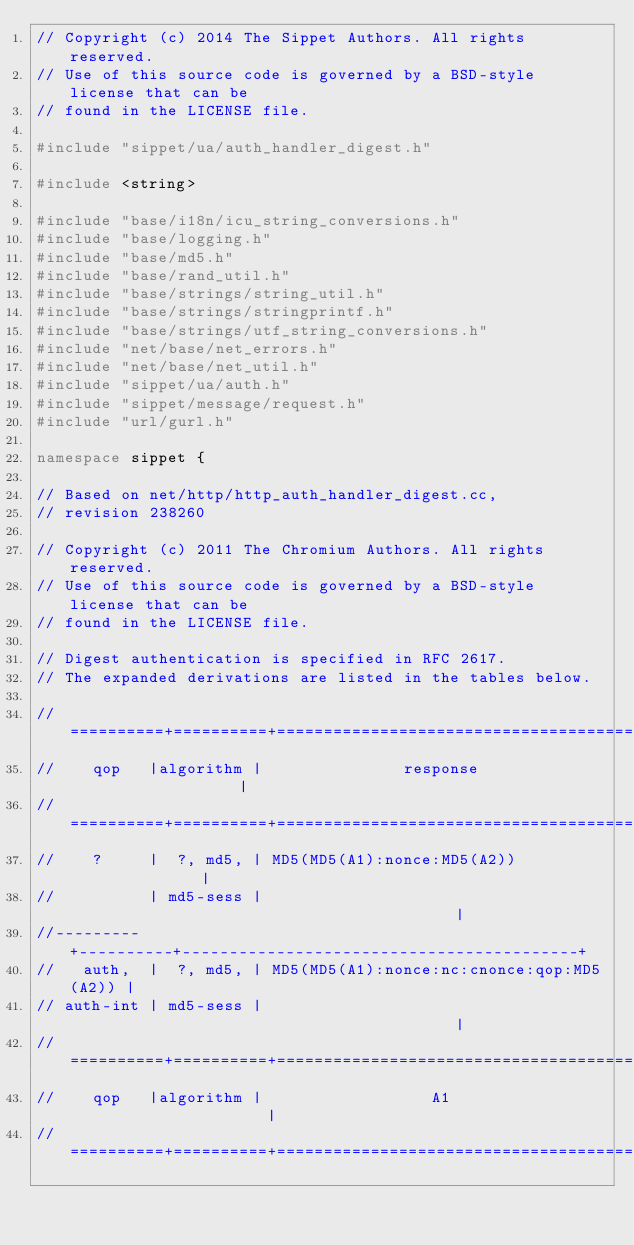<code> <loc_0><loc_0><loc_500><loc_500><_C++_>// Copyright (c) 2014 The Sippet Authors. All rights reserved.
// Use of this source code is governed by a BSD-style license that can be
// found in the LICENSE file.

#include "sippet/ua/auth_handler_digest.h"

#include <string>

#include "base/i18n/icu_string_conversions.h"
#include "base/logging.h"
#include "base/md5.h"
#include "base/rand_util.h"
#include "base/strings/string_util.h"
#include "base/strings/stringprintf.h"
#include "base/strings/utf_string_conversions.h"
#include "net/base/net_errors.h"
#include "net/base/net_util.h"
#include "sippet/ua/auth.h"
#include "sippet/message/request.h"
#include "url/gurl.h"

namespace sippet {

// Based on net/http/http_auth_handler_digest.cc,
// revision 238260

// Copyright (c) 2011 The Chromium Authors. All rights reserved.
// Use of this source code is governed by a BSD-style license that can be
// found in the LICENSE file.

// Digest authentication is specified in RFC 2617.
// The expanded derivations are listed in the tables below.

//==========+==========+==========================================+
//    qop   |algorithm |               response                   |
//==========+==========+==========================================+
//    ?     |  ?, md5, | MD5(MD5(A1):nonce:MD5(A2))               |
//          | md5-sess |                                          |
//--------- +----------+------------------------------------------+
//   auth,  |  ?, md5, | MD5(MD5(A1):nonce:nc:cnonce:qop:MD5(A2)) |
// auth-int | md5-sess |                                          |
//==========+==========+==========================================+
//    qop   |algorithm |                  A1                      |
//==========+==========+==========================================+</code> 